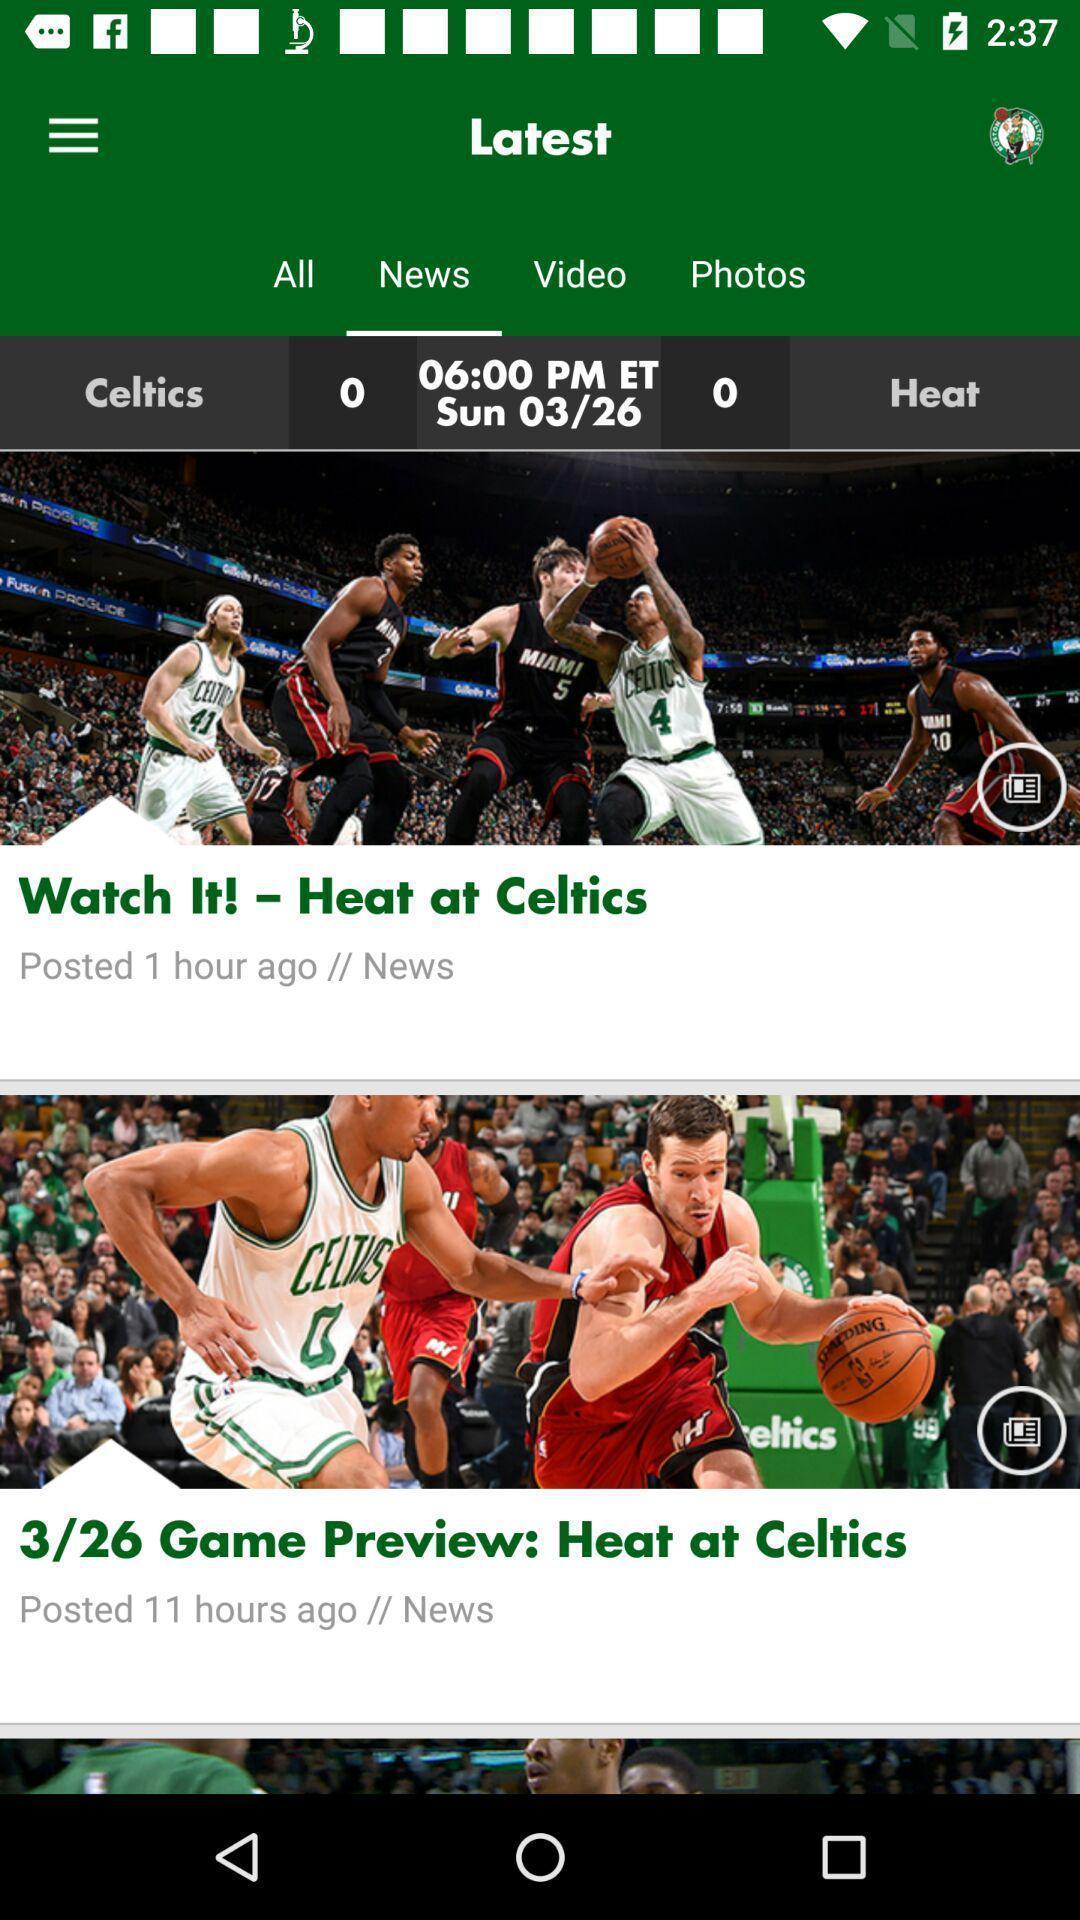What is the overall content of this screenshot? Screen displaying multiple sport articles information. 